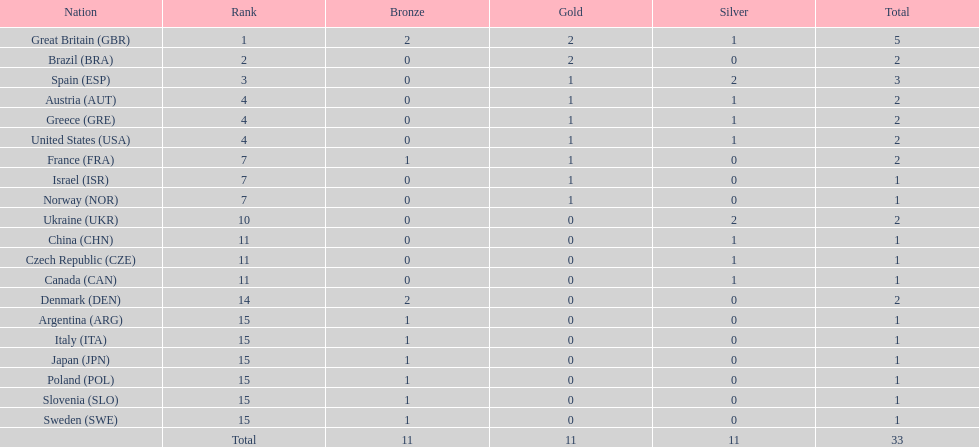Who won more gold medals than spain? Great Britain (GBR), Brazil (BRA). 